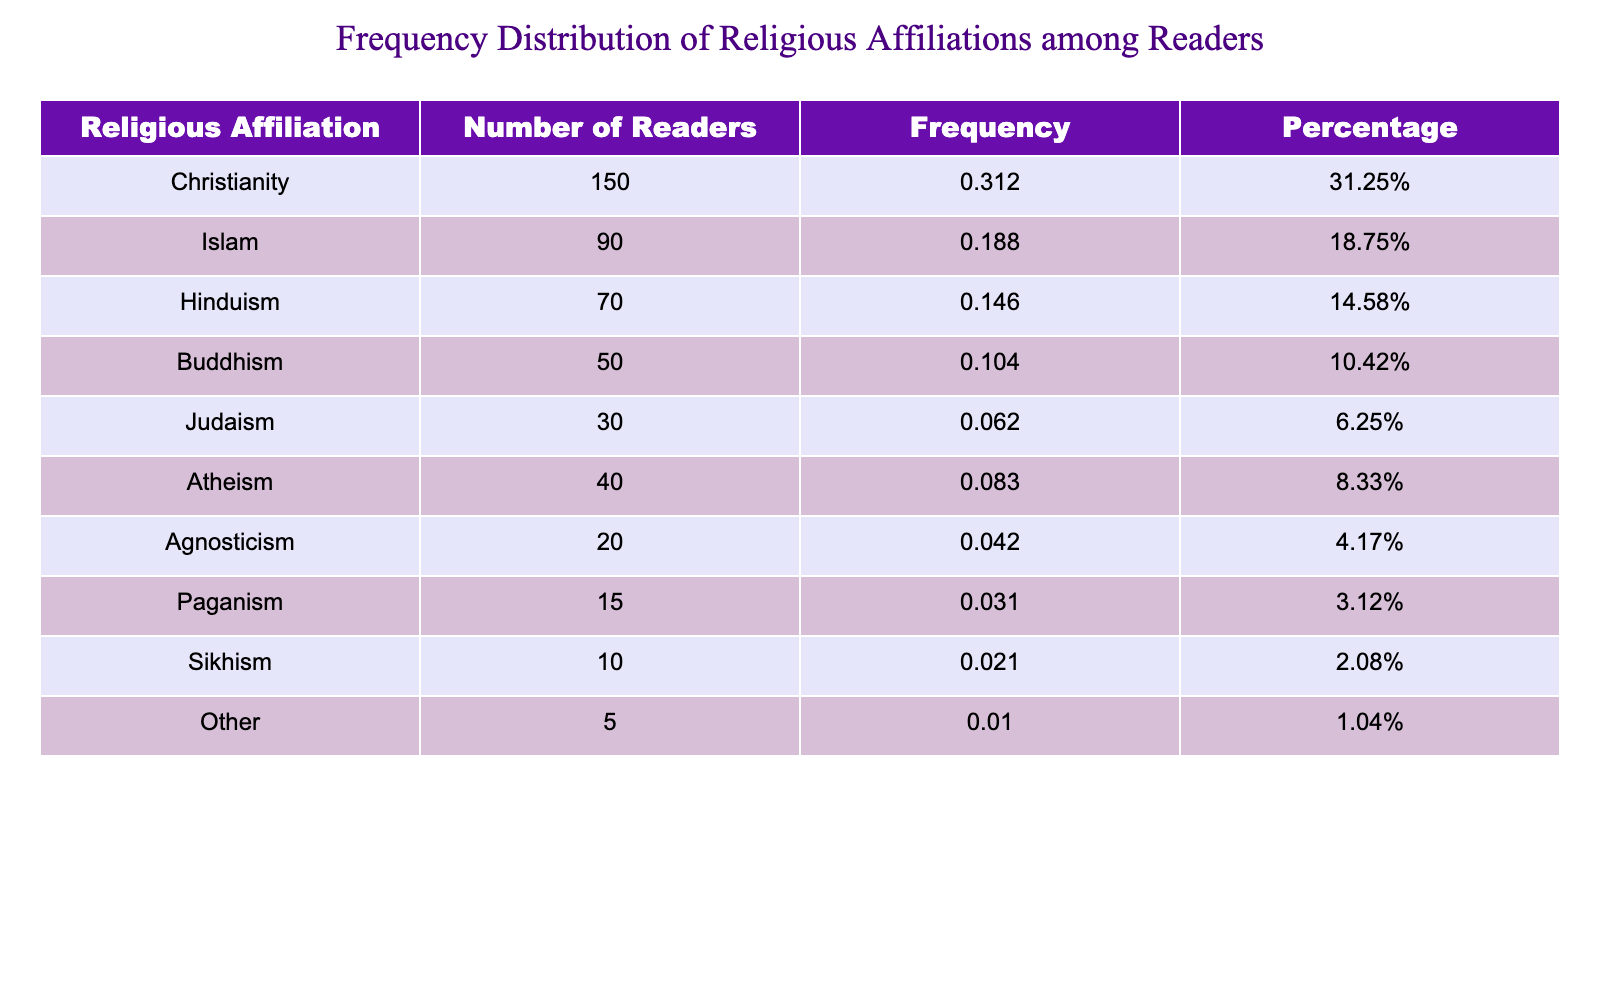What is the total number of readers who engaged with your book? To find the total number of readers, you need to sum the values of the 'Number_of_Readers' column. The values are 150 (Christianity) + 90 (Islam) + 70 (Hinduism) + 50 (Buddhism) + 30 (Judaism) + 40 (Atheism) + 20 (Agnosticism) + 15 (Paganism) + 10 (Sikhism) + 5 (Other) = 510.
Answer: 510 What percentage of the readership identifies as Islam? To find the percentage of readers that identify as Islam, look at the 'Number_of_Readers' for Islam, which is 90. The total number of readers is 510. The percentage is calculated by (90/510) * 100 = 17.65%.
Answer: 17.65% Which religious affiliation has the highest number of readers? By examining the 'Number_of_Readers' column, Christianity has the highest number of readers with a count of 150.
Answer: Christianity What is the combined number of readers who identify as Atheism and Agnosticism? To find the combined number of readers for both Atheism and Agnosticism, add their numbers: Atheism has 40 readers and Agnosticism has 20 readers. Thus, 40 + 20 = 60 combined readers.
Answer: 60 Is there a higher number of readers who identify as Buddhism or Atheism? Buddhism has 50 readers and Atheism has 40 readers. Comparing these values, Buddhism has a higher number of readers. Therefore, the statement is true.
Answer: True What is the frequency of readers identifying as Judaism? To find the frequency, take the number of readers who identify as Judaism, which is 30, and divide it by the total number of readers, 510. The frequency is calculated as 30/510 = approximately 0.0588.
Answer: 0.0588 If we exclude the "Other" category, what is the total number of readers for the remaining affiliations? The 'Other' category has 5 readers. Subtract this from the total readership of 510. So, 510 - 5 = 505 is the total number of readers excluding the Other category.
Answer: 505 How many more readers identify as Christianity compared to Paganism? Christianity has 150 readers and Paganism has 15 readers. To find how many more, subtract the number of Paganism readers from Christianity: 150 - 15 = 135.
Answer: 135 What is the average number of readers across all religious affiliations? To find the average, sum all readers (510) and divide by the number of affiliations (10): 510/10 = 51. So, the average number of readers is 51.
Answer: 51 